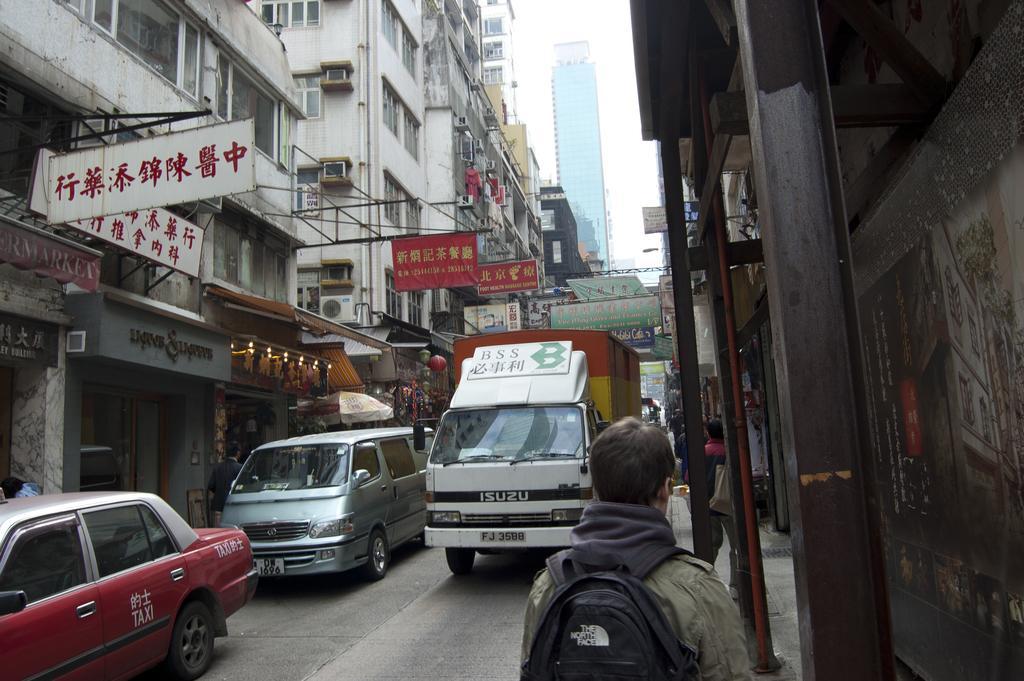Please provide a concise description of this image. This image is clicked on the road. There are vehicles moving on the road. To the right there is a walkway. There are people walking on the walkway. On the either sides of the road there are buildings. There are boards with text on the buildings. At the top there is the sky. 